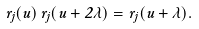Convert formula to latex. <formula><loc_0><loc_0><loc_500><loc_500>r _ { j } ( u ) \, r _ { j } ( u + 2 \lambda ) = r _ { j } ( u + \lambda ) .</formula> 